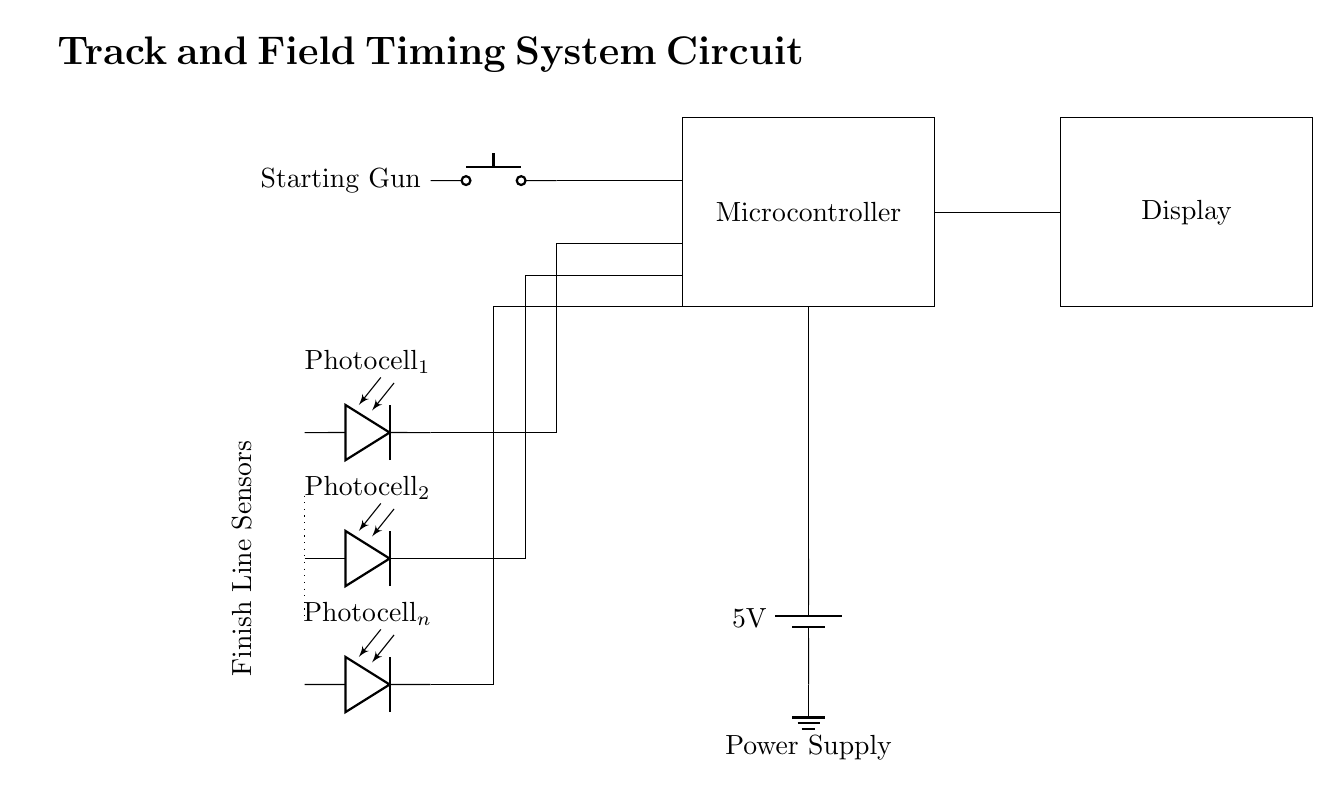What is the main component controlling the timing? The main component is the microcontroller, which processes signals from the starting gun and photocells.
Answer: Microcontroller How many photocells are shown in the circuit? There are three photocells, as indicated by the labeled diagrams in the circuit.
Answer: Three What is the voltage provided by the power supply? The power supply provides a voltage of 5 volts, which is indicated next to the battery symbol in the diagram.
Answer: 5 volts What triggers the starting signal in this timing system? The starting signal is triggered by the push button device, which represents the starting gun used in track events.
Answer: Starting gun How are the photocells connected to the microcontroller? The photocells are connected through direct lines, running into the microcontroller from different vertical positions, indicating a direct electrical connection.
Answer: Directly What is the purpose of the display in this circuit? The display's purpose is to show the timing results processed by the microcontroller after receiving signals from the photocells.
Answer: Show timing results Where is the ground connection located in the circuit? The ground connection is located under the power supply at the battery symbol, showing where the circuit is electrically grounded.
Answer: Under the battery 